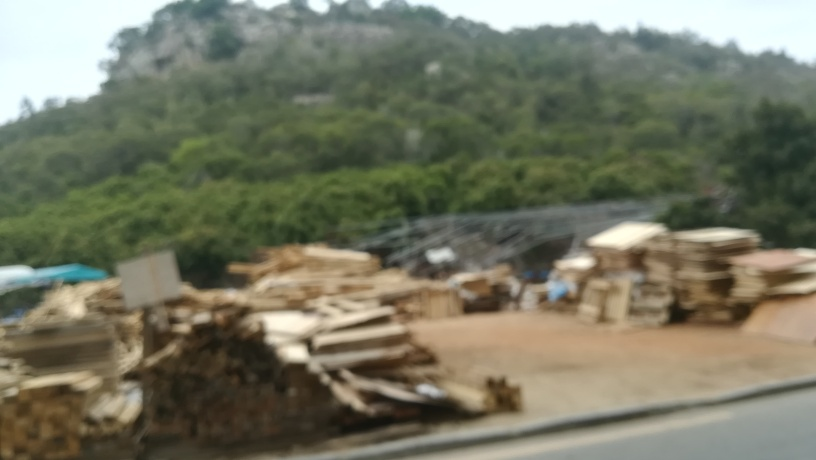Can you speculate about why this image might have been taken? Considering the motion blur and the composition, it’s possible this image was taken spontaneously, perhaps from inside a moving vehicle, capturing a moment of everyday activity without artistic intent. 